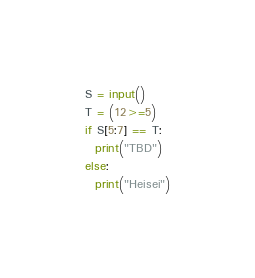<code> <loc_0><loc_0><loc_500><loc_500><_Python_>S = input()
T = (12>=5)
if S[5:7] == T:
  print("TBD")
else:
  print("Heisei")</code> 